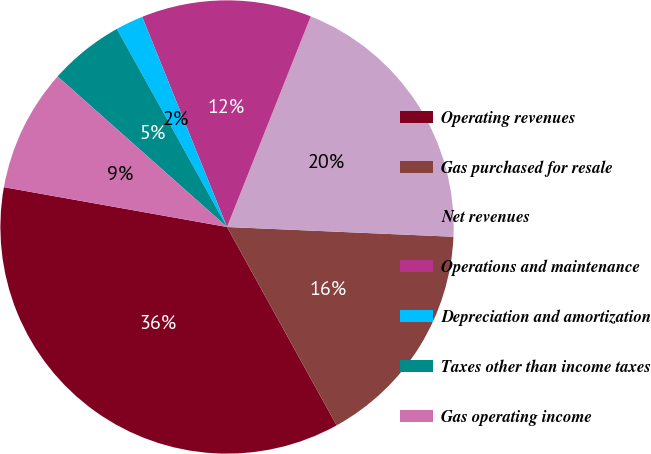<chart> <loc_0><loc_0><loc_500><loc_500><pie_chart><fcel>Operating revenues<fcel>Gas purchased for resale<fcel>Net revenues<fcel>Operations and maintenance<fcel>Depreciation and amortization<fcel>Taxes other than income taxes<fcel>Gas operating income<nl><fcel>35.84%<fcel>16.28%<fcel>19.66%<fcel>12.13%<fcel>1.97%<fcel>5.36%<fcel>8.75%<nl></chart> 